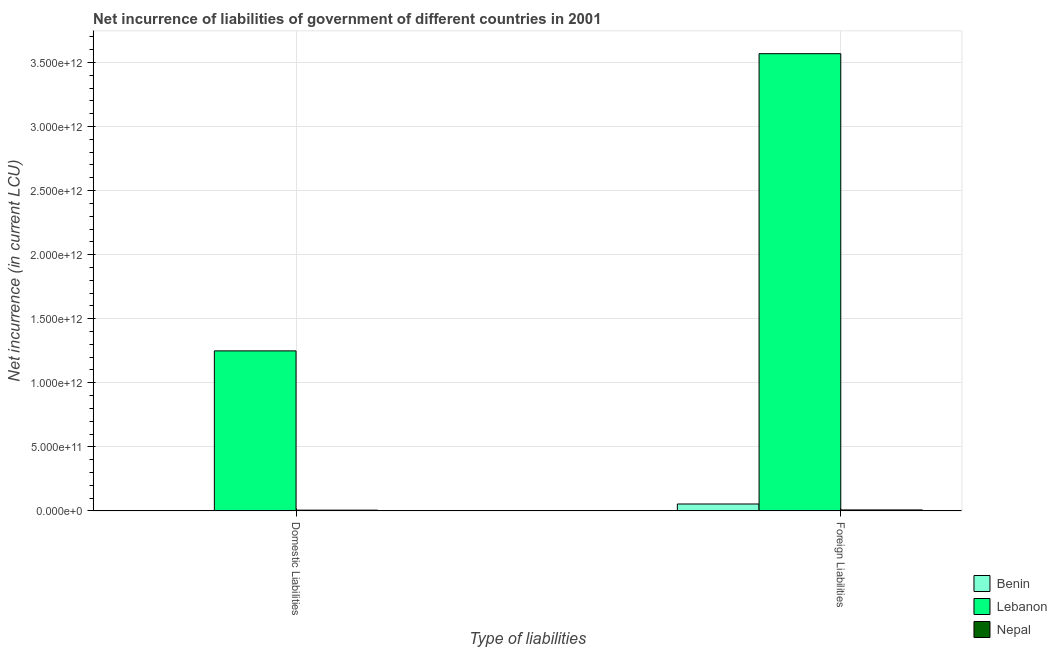How many groups of bars are there?
Your response must be concise. 2. How many bars are there on the 1st tick from the right?
Provide a short and direct response. 3. What is the label of the 1st group of bars from the left?
Offer a terse response. Domestic Liabilities. What is the net incurrence of foreign liabilities in Benin?
Your answer should be compact. 5.38e+1. Across all countries, what is the maximum net incurrence of domestic liabilities?
Keep it short and to the point. 1.25e+12. Across all countries, what is the minimum net incurrence of foreign liabilities?
Give a very brief answer. 7.54e+09. In which country was the net incurrence of domestic liabilities maximum?
Offer a very short reply. Lebanon. What is the total net incurrence of domestic liabilities in the graph?
Provide a succinct answer. 1.25e+12. What is the difference between the net incurrence of foreign liabilities in Lebanon and that in Benin?
Ensure brevity in your answer.  3.51e+12. What is the difference between the net incurrence of foreign liabilities in Benin and the net incurrence of domestic liabilities in Lebanon?
Your answer should be very brief. -1.19e+12. What is the average net incurrence of foreign liabilities per country?
Make the answer very short. 1.21e+12. What is the difference between the net incurrence of foreign liabilities and net incurrence of domestic liabilities in Lebanon?
Your response must be concise. 2.32e+12. In how many countries, is the net incurrence of domestic liabilities greater than 3100000000000 LCU?
Your answer should be very brief. 0. What is the ratio of the net incurrence of domestic liabilities in Lebanon to that in Nepal?
Your answer should be compact. 214.94. Is the net incurrence of foreign liabilities in Lebanon less than that in Benin?
Provide a short and direct response. No. In how many countries, is the net incurrence of foreign liabilities greater than the average net incurrence of foreign liabilities taken over all countries?
Provide a short and direct response. 1. How many countries are there in the graph?
Give a very brief answer. 3. What is the difference between two consecutive major ticks on the Y-axis?
Provide a succinct answer. 5.00e+11. Are the values on the major ticks of Y-axis written in scientific E-notation?
Keep it short and to the point. Yes. Does the graph contain grids?
Your answer should be compact. Yes. Where does the legend appear in the graph?
Your answer should be very brief. Bottom right. How many legend labels are there?
Provide a short and direct response. 3. What is the title of the graph?
Your answer should be compact. Net incurrence of liabilities of government of different countries in 2001. Does "Mexico" appear as one of the legend labels in the graph?
Provide a short and direct response. No. What is the label or title of the X-axis?
Ensure brevity in your answer.  Type of liabilities. What is the label or title of the Y-axis?
Your answer should be very brief. Net incurrence (in current LCU). What is the Net incurrence (in current LCU) in Benin in Domestic Liabilities?
Provide a short and direct response. 0. What is the Net incurrence (in current LCU) in Lebanon in Domestic Liabilities?
Offer a very short reply. 1.25e+12. What is the Net incurrence (in current LCU) in Nepal in Domestic Liabilities?
Make the answer very short. 5.81e+09. What is the Net incurrence (in current LCU) in Benin in Foreign Liabilities?
Make the answer very short. 5.38e+1. What is the Net incurrence (in current LCU) of Lebanon in Foreign Liabilities?
Ensure brevity in your answer.  3.57e+12. What is the Net incurrence (in current LCU) in Nepal in Foreign Liabilities?
Give a very brief answer. 7.54e+09. Across all Type of liabilities, what is the maximum Net incurrence (in current LCU) in Benin?
Your answer should be compact. 5.38e+1. Across all Type of liabilities, what is the maximum Net incurrence (in current LCU) in Lebanon?
Your answer should be compact. 3.57e+12. Across all Type of liabilities, what is the maximum Net incurrence (in current LCU) in Nepal?
Your response must be concise. 7.54e+09. Across all Type of liabilities, what is the minimum Net incurrence (in current LCU) in Lebanon?
Offer a very short reply. 1.25e+12. Across all Type of liabilities, what is the minimum Net incurrence (in current LCU) in Nepal?
Provide a succinct answer. 5.81e+09. What is the total Net incurrence (in current LCU) in Benin in the graph?
Offer a very short reply. 5.38e+1. What is the total Net incurrence (in current LCU) in Lebanon in the graph?
Provide a short and direct response. 4.82e+12. What is the total Net incurrence (in current LCU) of Nepal in the graph?
Your answer should be compact. 1.34e+1. What is the difference between the Net incurrence (in current LCU) of Lebanon in Domestic Liabilities and that in Foreign Liabilities?
Provide a succinct answer. -2.32e+12. What is the difference between the Net incurrence (in current LCU) in Nepal in Domestic Liabilities and that in Foreign Liabilities?
Ensure brevity in your answer.  -1.73e+09. What is the difference between the Net incurrence (in current LCU) in Lebanon in Domestic Liabilities and the Net incurrence (in current LCU) in Nepal in Foreign Liabilities?
Offer a terse response. 1.24e+12. What is the average Net incurrence (in current LCU) in Benin per Type of liabilities?
Give a very brief answer. 2.69e+1. What is the average Net incurrence (in current LCU) in Lebanon per Type of liabilities?
Provide a succinct answer. 2.41e+12. What is the average Net incurrence (in current LCU) of Nepal per Type of liabilities?
Your answer should be very brief. 6.68e+09. What is the difference between the Net incurrence (in current LCU) of Lebanon and Net incurrence (in current LCU) of Nepal in Domestic Liabilities?
Your answer should be very brief. 1.24e+12. What is the difference between the Net incurrence (in current LCU) in Benin and Net incurrence (in current LCU) in Lebanon in Foreign Liabilities?
Offer a very short reply. -3.51e+12. What is the difference between the Net incurrence (in current LCU) in Benin and Net incurrence (in current LCU) in Nepal in Foreign Liabilities?
Provide a succinct answer. 4.63e+1. What is the difference between the Net incurrence (in current LCU) in Lebanon and Net incurrence (in current LCU) in Nepal in Foreign Liabilities?
Keep it short and to the point. 3.56e+12. What is the ratio of the Net incurrence (in current LCU) of Lebanon in Domestic Liabilities to that in Foreign Liabilities?
Offer a terse response. 0.35. What is the ratio of the Net incurrence (in current LCU) of Nepal in Domestic Liabilities to that in Foreign Liabilities?
Give a very brief answer. 0.77. What is the difference between the highest and the second highest Net incurrence (in current LCU) of Lebanon?
Offer a very short reply. 2.32e+12. What is the difference between the highest and the second highest Net incurrence (in current LCU) in Nepal?
Your answer should be compact. 1.73e+09. What is the difference between the highest and the lowest Net incurrence (in current LCU) of Benin?
Offer a terse response. 5.38e+1. What is the difference between the highest and the lowest Net incurrence (in current LCU) in Lebanon?
Offer a terse response. 2.32e+12. What is the difference between the highest and the lowest Net incurrence (in current LCU) of Nepal?
Keep it short and to the point. 1.73e+09. 